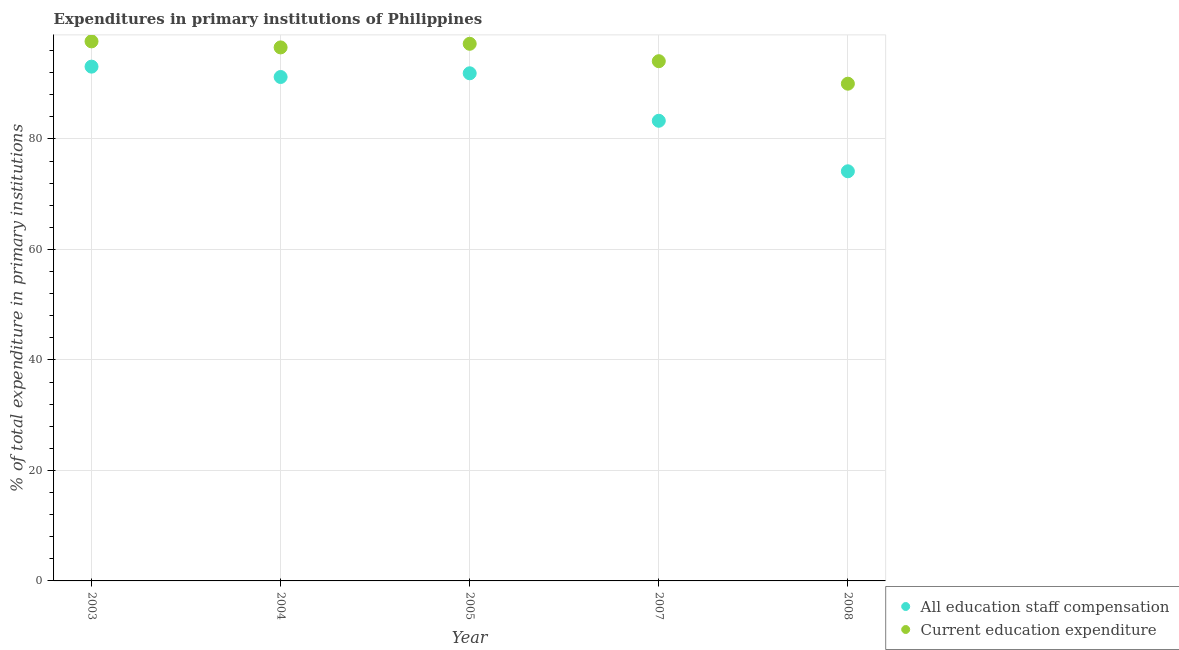Is the number of dotlines equal to the number of legend labels?
Provide a short and direct response. Yes. What is the expenditure in education in 2008?
Your response must be concise. 89.99. Across all years, what is the maximum expenditure in staff compensation?
Give a very brief answer. 93.08. Across all years, what is the minimum expenditure in education?
Your answer should be compact. 89.99. What is the total expenditure in staff compensation in the graph?
Make the answer very short. 433.58. What is the difference between the expenditure in staff compensation in 2003 and that in 2005?
Offer a very short reply. 1.2. What is the difference between the expenditure in education in 2003 and the expenditure in staff compensation in 2007?
Provide a short and direct response. 14.37. What is the average expenditure in education per year?
Keep it short and to the point. 95.1. In the year 2008, what is the difference between the expenditure in education and expenditure in staff compensation?
Your answer should be compact. 15.85. In how many years, is the expenditure in education greater than 88 %?
Your answer should be compact. 5. What is the ratio of the expenditure in staff compensation in 2003 to that in 2004?
Give a very brief answer. 1.02. Is the expenditure in staff compensation in 2003 less than that in 2007?
Your answer should be compact. No. What is the difference between the highest and the second highest expenditure in education?
Your answer should be compact. 0.44. What is the difference between the highest and the lowest expenditure in education?
Your response must be concise. 7.66. In how many years, is the expenditure in education greater than the average expenditure in education taken over all years?
Provide a short and direct response. 3. Is the sum of the expenditure in staff compensation in 2005 and 2008 greater than the maximum expenditure in education across all years?
Your answer should be very brief. Yes. How many dotlines are there?
Provide a succinct answer. 2. How many years are there in the graph?
Make the answer very short. 5. Does the graph contain any zero values?
Offer a terse response. No. Does the graph contain grids?
Your answer should be very brief. Yes. How many legend labels are there?
Keep it short and to the point. 2. How are the legend labels stacked?
Your answer should be very brief. Vertical. What is the title of the graph?
Your answer should be very brief. Expenditures in primary institutions of Philippines. Does "Resident" appear as one of the legend labels in the graph?
Your response must be concise. No. What is the label or title of the X-axis?
Provide a succinct answer. Year. What is the label or title of the Y-axis?
Provide a short and direct response. % of total expenditure in primary institutions. What is the % of total expenditure in primary institutions of All education staff compensation in 2003?
Your response must be concise. 93.08. What is the % of total expenditure in primary institutions of Current education expenditure in 2003?
Provide a short and direct response. 97.65. What is the % of total expenditure in primary institutions in All education staff compensation in 2004?
Give a very brief answer. 91.2. What is the % of total expenditure in primary institutions in Current education expenditure in 2004?
Make the answer very short. 96.56. What is the % of total expenditure in primary institutions in All education staff compensation in 2005?
Give a very brief answer. 91.88. What is the % of total expenditure in primary institutions of Current education expenditure in 2005?
Provide a succinct answer. 97.21. What is the % of total expenditure in primary institutions in All education staff compensation in 2007?
Make the answer very short. 83.28. What is the % of total expenditure in primary institutions in Current education expenditure in 2007?
Give a very brief answer. 94.06. What is the % of total expenditure in primary institutions in All education staff compensation in 2008?
Offer a very short reply. 74.14. What is the % of total expenditure in primary institutions in Current education expenditure in 2008?
Your response must be concise. 89.99. Across all years, what is the maximum % of total expenditure in primary institutions of All education staff compensation?
Give a very brief answer. 93.08. Across all years, what is the maximum % of total expenditure in primary institutions in Current education expenditure?
Your response must be concise. 97.65. Across all years, what is the minimum % of total expenditure in primary institutions of All education staff compensation?
Make the answer very short. 74.14. Across all years, what is the minimum % of total expenditure in primary institutions in Current education expenditure?
Your answer should be compact. 89.99. What is the total % of total expenditure in primary institutions of All education staff compensation in the graph?
Make the answer very short. 433.58. What is the total % of total expenditure in primary institutions in Current education expenditure in the graph?
Provide a short and direct response. 475.48. What is the difference between the % of total expenditure in primary institutions of All education staff compensation in 2003 and that in 2004?
Your response must be concise. 1.87. What is the difference between the % of total expenditure in primary institutions of Current education expenditure in 2003 and that in 2004?
Make the answer very short. 1.09. What is the difference between the % of total expenditure in primary institutions in All education staff compensation in 2003 and that in 2005?
Your response must be concise. 1.2. What is the difference between the % of total expenditure in primary institutions in Current education expenditure in 2003 and that in 2005?
Offer a very short reply. 0.44. What is the difference between the % of total expenditure in primary institutions in All education staff compensation in 2003 and that in 2007?
Your answer should be very brief. 9.8. What is the difference between the % of total expenditure in primary institutions in Current education expenditure in 2003 and that in 2007?
Your answer should be compact. 3.59. What is the difference between the % of total expenditure in primary institutions of All education staff compensation in 2003 and that in 2008?
Keep it short and to the point. 18.94. What is the difference between the % of total expenditure in primary institutions of Current education expenditure in 2003 and that in 2008?
Ensure brevity in your answer.  7.66. What is the difference between the % of total expenditure in primary institutions of All education staff compensation in 2004 and that in 2005?
Keep it short and to the point. -0.67. What is the difference between the % of total expenditure in primary institutions in Current education expenditure in 2004 and that in 2005?
Give a very brief answer. -0.65. What is the difference between the % of total expenditure in primary institutions in All education staff compensation in 2004 and that in 2007?
Give a very brief answer. 7.92. What is the difference between the % of total expenditure in primary institutions of Current education expenditure in 2004 and that in 2007?
Provide a succinct answer. 2.5. What is the difference between the % of total expenditure in primary institutions of All education staff compensation in 2004 and that in 2008?
Offer a terse response. 17.07. What is the difference between the % of total expenditure in primary institutions in Current education expenditure in 2004 and that in 2008?
Offer a terse response. 6.57. What is the difference between the % of total expenditure in primary institutions in All education staff compensation in 2005 and that in 2007?
Offer a terse response. 8.59. What is the difference between the % of total expenditure in primary institutions in Current education expenditure in 2005 and that in 2007?
Your response must be concise. 3.15. What is the difference between the % of total expenditure in primary institutions in All education staff compensation in 2005 and that in 2008?
Your response must be concise. 17.74. What is the difference between the % of total expenditure in primary institutions of Current education expenditure in 2005 and that in 2008?
Ensure brevity in your answer.  7.22. What is the difference between the % of total expenditure in primary institutions in All education staff compensation in 2007 and that in 2008?
Give a very brief answer. 9.14. What is the difference between the % of total expenditure in primary institutions of Current education expenditure in 2007 and that in 2008?
Keep it short and to the point. 4.07. What is the difference between the % of total expenditure in primary institutions of All education staff compensation in 2003 and the % of total expenditure in primary institutions of Current education expenditure in 2004?
Keep it short and to the point. -3.48. What is the difference between the % of total expenditure in primary institutions of All education staff compensation in 2003 and the % of total expenditure in primary institutions of Current education expenditure in 2005?
Provide a short and direct response. -4.13. What is the difference between the % of total expenditure in primary institutions in All education staff compensation in 2003 and the % of total expenditure in primary institutions in Current education expenditure in 2007?
Your response must be concise. -0.99. What is the difference between the % of total expenditure in primary institutions of All education staff compensation in 2003 and the % of total expenditure in primary institutions of Current education expenditure in 2008?
Ensure brevity in your answer.  3.09. What is the difference between the % of total expenditure in primary institutions of All education staff compensation in 2004 and the % of total expenditure in primary institutions of Current education expenditure in 2005?
Keep it short and to the point. -6.01. What is the difference between the % of total expenditure in primary institutions of All education staff compensation in 2004 and the % of total expenditure in primary institutions of Current education expenditure in 2007?
Make the answer very short. -2.86. What is the difference between the % of total expenditure in primary institutions of All education staff compensation in 2004 and the % of total expenditure in primary institutions of Current education expenditure in 2008?
Ensure brevity in your answer.  1.21. What is the difference between the % of total expenditure in primary institutions of All education staff compensation in 2005 and the % of total expenditure in primary institutions of Current education expenditure in 2007?
Ensure brevity in your answer.  -2.19. What is the difference between the % of total expenditure in primary institutions of All education staff compensation in 2005 and the % of total expenditure in primary institutions of Current education expenditure in 2008?
Make the answer very short. 1.88. What is the difference between the % of total expenditure in primary institutions in All education staff compensation in 2007 and the % of total expenditure in primary institutions in Current education expenditure in 2008?
Offer a terse response. -6.71. What is the average % of total expenditure in primary institutions of All education staff compensation per year?
Make the answer very short. 86.72. What is the average % of total expenditure in primary institutions in Current education expenditure per year?
Provide a short and direct response. 95.1. In the year 2003, what is the difference between the % of total expenditure in primary institutions of All education staff compensation and % of total expenditure in primary institutions of Current education expenditure?
Keep it short and to the point. -4.57. In the year 2004, what is the difference between the % of total expenditure in primary institutions of All education staff compensation and % of total expenditure in primary institutions of Current education expenditure?
Offer a very short reply. -5.35. In the year 2005, what is the difference between the % of total expenditure in primary institutions of All education staff compensation and % of total expenditure in primary institutions of Current education expenditure?
Your response must be concise. -5.34. In the year 2007, what is the difference between the % of total expenditure in primary institutions of All education staff compensation and % of total expenditure in primary institutions of Current education expenditure?
Your response must be concise. -10.78. In the year 2008, what is the difference between the % of total expenditure in primary institutions of All education staff compensation and % of total expenditure in primary institutions of Current education expenditure?
Offer a very short reply. -15.85. What is the ratio of the % of total expenditure in primary institutions of All education staff compensation in 2003 to that in 2004?
Make the answer very short. 1.02. What is the ratio of the % of total expenditure in primary institutions of Current education expenditure in 2003 to that in 2004?
Give a very brief answer. 1.01. What is the ratio of the % of total expenditure in primary institutions of All education staff compensation in 2003 to that in 2005?
Ensure brevity in your answer.  1.01. What is the ratio of the % of total expenditure in primary institutions in Current education expenditure in 2003 to that in 2005?
Your response must be concise. 1. What is the ratio of the % of total expenditure in primary institutions in All education staff compensation in 2003 to that in 2007?
Ensure brevity in your answer.  1.12. What is the ratio of the % of total expenditure in primary institutions of Current education expenditure in 2003 to that in 2007?
Give a very brief answer. 1.04. What is the ratio of the % of total expenditure in primary institutions of All education staff compensation in 2003 to that in 2008?
Ensure brevity in your answer.  1.26. What is the ratio of the % of total expenditure in primary institutions of Current education expenditure in 2003 to that in 2008?
Provide a short and direct response. 1.09. What is the ratio of the % of total expenditure in primary institutions in Current education expenditure in 2004 to that in 2005?
Make the answer very short. 0.99. What is the ratio of the % of total expenditure in primary institutions in All education staff compensation in 2004 to that in 2007?
Ensure brevity in your answer.  1.1. What is the ratio of the % of total expenditure in primary institutions in Current education expenditure in 2004 to that in 2007?
Provide a succinct answer. 1.03. What is the ratio of the % of total expenditure in primary institutions of All education staff compensation in 2004 to that in 2008?
Provide a short and direct response. 1.23. What is the ratio of the % of total expenditure in primary institutions of Current education expenditure in 2004 to that in 2008?
Offer a very short reply. 1.07. What is the ratio of the % of total expenditure in primary institutions in All education staff compensation in 2005 to that in 2007?
Ensure brevity in your answer.  1.1. What is the ratio of the % of total expenditure in primary institutions in Current education expenditure in 2005 to that in 2007?
Your answer should be very brief. 1.03. What is the ratio of the % of total expenditure in primary institutions in All education staff compensation in 2005 to that in 2008?
Your answer should be very brief. 1.24. What is the ratio of the % of total expenditure in primary institutions of Current education expenditure in 2005 to that in 2008?
Your answer should be compact. 1.08. What is the ratio of the % of total expenditure in primary institutions of All education staff compensation in 2007 to that in 2008?
Give a very brief answer. 1.12. What is the ratio of the % of total expenditure in primary institutions in Current education expenditure in 2007 to that in 2008?
Offer a very short reply. 1.05. What is the difference between the highest and the second highest % of total expenditure in primary institutions of All education staff compensation?
Ensure brevity in your answer.  1.2. What is the difference between the highest and the second highest % of total expenditure in primary institutions in Current education expenditure?
Keep it short and to the point. 0.44. What is the difference between the highest and the lowest % of total expenditure in primary institutions in All education staff compensation?
Give a very brief answer. 18.94. What is the difference between the highest and the lowest % of total expenditure in primary institutions of Current education expenditure?
Provide a succinct answer. 7.66. 